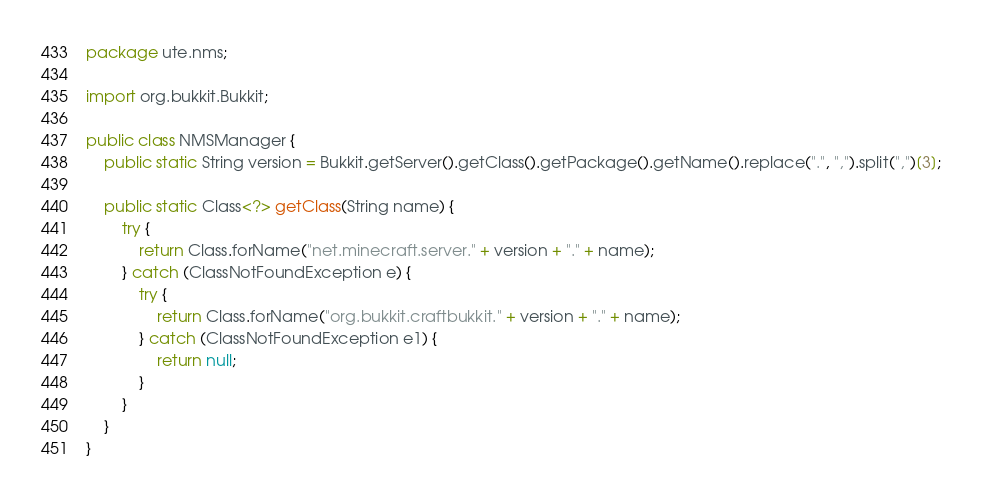<code> <loc_0><loc_0><loc_500><loc_500><_Java_>package ute.nms;

import org.bukkit.Bukkit;

public class NMSManager {
    public static String version = Bukkit.getServer().getClass().getPackage().getName().replace(".", ",").split(",")[3];

    public static Class<?> getClass(String name) {
        try {
            return Class.forName("net.minecraft.server." + version + "." + name);
        } catch (ClassNotFoundException e) {
            try {
                return Class.forName("org.bukkit.craftbukkit." + version + "." + name);
            } catch (ClassNotFoundException e1) {
                return null;
            }
        }
    }
}
</code> 